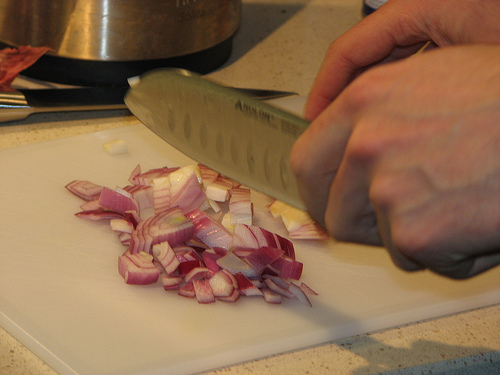<image>
Can you confirm if the man is on the knife? No. The man is not positioned on the knife. They may be near each other, but the man is not supported by or resting on top of the knife. 